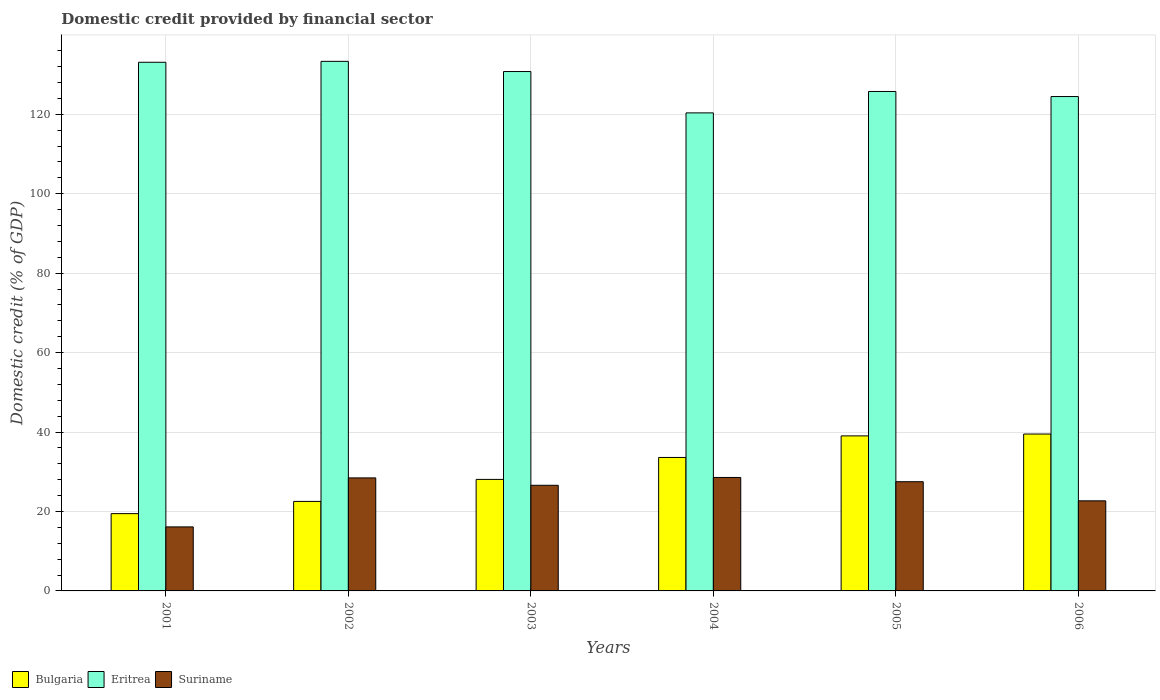Are the number of bars per tick equal to the number of legend labels?
Give a very brief answer. Yes. Are the number of bars on each tick of the X-axis equal?
Provide a short and direct response. Yes. What is the domestic credit in Bulgaria in 2004?
Keep it short and to the point. 33.6. Across all years, what is the maximum domestic credit in Eritrea?
Make the answer very short. 133.31. Across all years, what is the minimum domestic credit in Bulgaria?
Your response must be concise. 19.46. In which year was the domestic credit in Bulgaria minimum?
Your answer should be compact. 2001. What is the total domestic credit in Suriname in the graph?
Make the answer very short. 149.89. What is the difference between the domestic credit in Eritrea in 2001 and that in 2006?
Ensure brevity in your answer.  8.63. What is the difference between the domestic credit in Suriname in 2003 and the domestic credit in Bulgaria in 2004?
Ensure brevity in your answer.  -7.01. What is the average domestic credit in Suriname per year?
Ensure brevity in your answer.  24.98. In the year 2005, what is the difference between the domestic credit in Eritrea and domestic credit in Suriname?
Your answer should be very brief. 98.24. In how many years, is the domestic credit in Eritrea greater than 24 %?
Your answer should be very brief. 6. What is the ratio of the domestic credit in Eritrea in 2002 to that in 2004?
Offer a very short reply. 1.11. Is the domestic credit in Suriname in 2002 less than that in 2005?
Your response must be concise. No. What is the difference between the highest and the second highest domestic credit in Eritrea?
Make the answer very short. 0.23. What is the difference between the highest and the lowest domestic credit in Bulgaria?
Ensure brevity in your answer.  20.04. What does the 3rd bar from the left in 2001 represents?
Give a very brief answer. Suriname. What does the 1st bar from the right in 2003 represents?
Provide a short and direct response. Suriname. Is it the case that in every year, the sum of the domestic credit in Bulgaria and domestic credit in Suriname is greater than the domestic credit in Eritrea?
Ensure brevity in your answer.  No. Are all the bars in the graph horizontal?
Ensure brevity in your answer.  No. Are the values on the major ticks of Y-axis written in scientific E-notation?
Keep it short and to the point. No. Does the graph contain any zero values?
Give a very brief answer. No. Where does the legend appear in the graph?
Keep it short and to the point. Bottom left. How many legend labels are there?
Your response must be concise. 3. What is the title of the graph?
Your answer should be very brief. Domestic credit provided by financial sector. Does "Bulgaria" appear as one of the legend labels in the graph?
Give a very brief answer. Yes. What is the label or title of the Y-axis?
Keep it short and to the point. Domestic credit (% of GDP). What is the Domestic credit (% of GDP) in Bulgaria in 2001?
Keep it short and to the point. 19.46. What is the Domestic credit (% of GDP) in Eritrea in 2001?
Your answer should be very brief. 133.08. What is the Domestic credit (% of GDP) in Suriname in 2001?
Keep it short and to the point. 16.12. What is the Domestic credit (% of GDP) of Bulgaria in 2002?
Ensure brevity in your answer.  22.53. What is the Domestic credit (% of GDP) of Eritrea in 2002?
Provide a succinct answer. 133.31. What is the Domestic credit (% of GDP) of Suriname in 2002?
Provide a short and direct response. 28.45. What is the Domestic credit (% of GDP) in Bulgaria in 2003?
Offer a terse response. 28.07. What is the Domestic credit (% of GDP) in Eritrea in 2003?
Provide a short and direct response. 130.74. What is the Domestic credit (% of GDP) of Suriname in 2003?
Offer a terse response. 26.59. What is the Domestic credit (% of GDP) in Bulgaria in 2004?
Your response must be concise. 33.6. What is the Domestic credit (% of GDP) of Eritrea in 2004?
Your answer should be very brief. 120.34. What is the Domestic credit (% of GDP) in Suriname in 2004?
Offer a very short reply. 28.56. What is the Domestic credit (% of GDP) in Bulgaria in 2005?
Provide a short and direct response. 39.03. What is the Domestic credit (% of GDP) of Eritrea in 2005?
Keep it short and to the point. 125.73. What is the Domestic credit (% of GDP) in Suriname in 2005?
Offer a very short reply. 27.49. What is the Domestic credit (% of GDP) of Bulgaria in 2006?
Your response must be concise. 39.49. What is the Domestic credit (% of GDP) in Eritrea in 2006?
Keep it short and to the point. 124.45. What is the Domestic credit (% of GDP) of Suriname in 2006?
Keep it short and to the point. 22.68. Across all years, what is the maximum Domestic credit (% of GDP) of Bulgaria?
Your answer should be compact. 39.49. Across all years, what is the maximum Domestic credit (% of GDP) of Eritrea?
Make the answer very short. 133.31. Across all years, what is the maximum Domestic credit (% of GDP) of Suriname?
Keep it short and to the point. 28.56. Across all years, what is the minimum Domestic credit (% of GDP) in Bulgaria?
Offer a terse response. 19.46. Across all years, what is the minimum Domestic credit (% of GDP) of Eritrea?
Your answer should be compact. 120.34. Across all years, what is the minimum Domestic credit (% of GDP) in Suriname?
Your response must be concise. 16.12. What is the total Domestic credit (% of GDP) of Bulgaria in the graph?
Provide a succinct answer. 182.18. What is the total Domestic credit (% of GDP) in Eritrea in the graph?
Give a very brief answer. 767.64. What is the total Domestic credit (% of GDP) in Suriname in the graph?
Give a very brief answer. 149.89. What is the difference between the Domestic credit (% of GDP) in Bulgaria in 2001 and that in 2002?
Ensure brevity in your answer.  -3.07. What is the difference between the Domestic credit (% of GDP) of Eritrea in 2001 and that in 2002?
Offer a terse response. -0.23. What is the difference between the Domestic credit (% of GDP) of Suriname in 2001 and that in 2002?
Your response must be concise. -12.33. What is the difference between the Domestic credit (% of GDP) in Bulgaria in 2001 and that in 2003?
Provide a short and direct response. -8.62. What is the difference between the Domestic credit (% of GDP) in Eritrea in 2001 and that in 2003?
Keep it short and to the point. 2.33. What is the difference between the Domestic credit (% of GDP) in Suriname in 2001 and that in 2003?
Offer a terse response. -10.47. What is the difference between the Domestic credit (% of GDP) in Bulgaria in 2001 and that in 2004?
Ensure brevity in your answer.  -14.14. What is the difference between the Domestic credit (% of GDP) of Eritrea in 2001 and that in 2004?
Your response must be concise. 12.74. What is the difference between the Domestic credit (% of GDP) of Suriname in 2001 and that in 2004?
Keep it short and to the point. -12.45. What is the difference between the Domestic credit (% of GDP) of Bulgaria in 2001 and that in 2005?
Give a very brief answer. -19.57. What is the difference between the Domestic credit (% of GDP) of Eritrea in 2001 and that in 2005?
Keep it short and to the point. 7.35. What is the difference between the Domestic credit (% of GDP) of Suriname in 2001 and that in 2005?
Your response must be concise. -11.37. What is the difference between the Domestic credit (% of GDP) in Bulgaria in 2001 and that in 2006?
Your answer should be compact. -20.04. What is the difference between the Domestic credit (% of GDP) in Eritrea in 2001 and that in 2006?
Offer a very short reply. 8.63. What is the difference between the Domestic credit (% of GDP) in Suriname in 2001 and that in 2006?
Make the answer very short. -6.56. What is the difference between the Domestic credit (% of GDP) in Bulgaria in 2002 and that in 2003?
Ensure brevity in your answer.  -5.54. What is the difference between the Domestic credit (% of GDP) in Eritrea in 2002 and that in 2003?
Offer a very short reply. 2.56. What is the difference between the Domestic credit (% of GDP) of Suriname in 2002 and that in 2003?
Offer a terse response. 1.86. What is the difference between the Domestic credit (% of GDP) of Bulgaria in 2002 and that in 2004?
Provide a succinct answer. -11.06. What is the difference between the Domestic credit (% of GDP) of Eritrea in 2002 and that in 2004?
Offer a terse response. 12.97. What is the difference between the Domestic credit (% of GDP) in Suriname in 2002 and that in 2004?
Ensure brevity in your answer.  -0.11. What is the difference between the Domestic credit (% of GDP) in Bulgaria in 2002 and that in 2005?
Your response must be concise. -16.5. What is the difference between the Domestic credit (% of GDP) in Eritrea in 2002 and that in 2005?
Make the answer very short. 7.58. What is the difference between the Domestic credit (% of GDP) in Suriname in 2002 and that in 2005?
Keep it short and to the point. 0.96. What is the difference between the Domestic credit (% of GDP) of Bulgaria in 2002 and that in 2006?
Provide a succinct answer. -16.96. What is the difference between the Domestic credit (% of GDP) of Eritrea in 2002 and that in 2006?
Provide a short and direct response. 8.86. What is the difference between the Domestic credit (% of GDP) in Suriname in 2002 and that in 2006?
Ensure brevity in your answer.  5.77. What is the difference between the Domestic credit (% of GDP) in Bulgaria in 2003 and that in 2004?
Your answer should be compact. -5.52. What is the difference between the Domestic credit (% of GDP) of Eritrea in 2003 and that in 2004?
Offer a terse response. 10.41. What is the difference between the Domestic credit (% of GDP) in Suriname in 2003 and that in 2004?
Your response must be concise. -1.97. What is the difference between the Domestic credit (% of GDP) in Bulgaria in 2003 and that in 2005?
Keep it short and to the point. -10.95. What is the difference between the Domestic credit (% of GDP) in Eritrea in 2003 and that in 2005?
Provide a succinct answer. 5.02. What is the difference between the Domestic credit (% of GDP) in Suriname in 2003 and that in 2005?
Ensure brevity in your answer.  -0.9. What is the difference between the Domestic credit (% of GDP) in Bulgaria in 2003 and that in 2006?
Offer a very short reply. -11.42. What is the difference between the Domestic credit (% of GDP) of Eritrea in 2003 and that in 2006?
Your response must be concise. 6.29. What is the difference between the Domestic credit (% of GDP) in Suriname in 2003 and that in 2006?
Offer a very short reply. 3.91. What is the difference between the Domestic credit (% of GDP) in Bulgaria in 2004 and that in 2005?
Your response must be concise. -5.43. What is the difference between the Domestic credit (% of GDP) of Eritrea in 2004 and that in 2005?
Your response must be concise. -5.39. What is the difference between the Domestic credit (% of GDP) of Suriname in 2004 and that in 2005?
Offer a very short reply. 1.07. What is the difference between the Domestic credit (% of GDP) of Bulgaria in 2004 and that in 2006?
Give a very brief answer. -5.9. What is the difference between the Domestic credit (% of GDP) in Eritrea in 2004 and that in 2006?
Make the answer very short. -4.11. What is the difference between the Domestic credit (% of GDP) in Suriname in 2004 and that in 2006?
Provide a short and direct response. 5.89. What is the difference between the Domestic credit (% of GDP) of Bulgaria in 2005 and that in 2006?
Your answer should be compact. -0.47. What is the difference between the Domestic credit (% of GDP) in Eritrea in 2005 and that in 2006?
Give a very brief answer. 1.28. What is the difference between the Domestic credit (% of GDP) in Suriname in 2005 and that in 2006?
Your response must be concise. 4.81. What is the difference between the Domestic credit (% of GDP) of Bulgaria in 2001 and the Domestic credit (% of GDP) of Eritrea in 2002?
Offer a terse response. -113.85. What is the difference between the Domestic credit (% of GDP) of Bulgaria in 2001 and the Domestic credit (% of GDP) of Suriname in 2002?
Your answer should be compact. -8.99. What is the difference between the Domestic credit (% of GDP) in Eritrea in 2001 and the Domestic credit (% of GDP) in Suriname in 2002?
Make the answer very short. 104.63. What is the difference between the Domestic credit (% of GDP) of Bulgaria in 2001 and the Domestic credit (% of GDP) of Eritrea in 2003?
Your answer should be very brief. -111.29. What is the difference between the Domestic credit (% of GDP) in Bulgaria in 2001 and the Domestic credit (% of GDP) in Suriname in 2003?
Your response must be concise. -7.13. What is the difference between the Domestic credit (% of GDP) of Eritrea in 2001 and the Domestic credit (% of GDP) of Suriname in 2003?
Your answer should be very brief. 106.49. What is the difference between the Domestic credit (% of GDP) in Bulgaria in 2001 and the Domestic credit (% of GDP) in Eritrea in 2004?
Ensure brevity in your answer.  -100.88. What is the difference between the Domestic credit (% of GDP) of Bulgaria in 2001 and the Domestic credit (% of GDP) of Suriname in 2004?
Provide a succinct answer. -9.11. What is the difference between the Domestic credit (% of GDP) of Eritrea in 2001 and the Domestic credit (% of GDP) of Suriname in 2004?
Provide a short and direct response. 104.52. What is the difference between the Domestic credit (% of GDP) of Bulgaria in 2001 and the Domestic credit (% of GDP) of Eritrea in 2005?
Provide a short and direct response. -106.27. What is the difference between the Domestic credit (% of GDP) in Bulgaria in 2001 and the Domestic credit (% of GDP) in Suriname in 2005?
Offer a terse response. -8.03. What is the difference between the Domestic credit (% of GDP) in Eritrea in 2001 and the Domestic credit (% of GDP) in Suriname in 2005?
Your response must be concise. 105.59. What is the difference between the Domestic credit (% of GDP) of Bulgaria in 2001 and the Domestic credit (% of GDP) of Eritrea in 2006?
Offer a very short reply. -104.99. What is the difference between the Domestic credit (% of GDP) in Bulgaria in 2001 and the Domestic credit (% of GDP) in Suriname in 2006?
Offer a very short reply. -3.22. What is the difference between the Domestic credit (% of GDP) in Eritrea in 2001 and the Domestic credit (% of GDP) in Suriname in 2006?
Keep it short and to the point. 110.4. What is the difference between the Domestic credit (% of GDP) in Bulgaria in 2002 and the Domestic credit (% of GDP) in Eritrea in 2003?
Offer a terse response. -108.21. What is the difference between the Domestic credit (% of GDP) of Bulgaria in 2002 and the Domestic credit (% of GDP) of Suriname in 2003?
Your response must be concise. -4.06. What is the difference between the Domestic credit (% of GDP) of Eritrea in 2002 and the Domestic credit (% of GDP) of Suriname in 2003?
Keep it short and to the point. 106.72. What is the difference between the Domestic credit (% of GDP) of Bulgaria in 2002 and the Domestic credit (% of GDP) of Eritrea in 2004?
Your response must be concise. -97.8. What is the difference between the Domestic credit (% of GDP) in Bulgaria in 2002 and the Domestic credit (% of GDP) in Suriname in 2004?
Provide a short and direct response. -6.03. What is the difference between the Domestic credit (% of GDP) of Eritrea in 2002 and the Domestic credit (% of GDP) of Suriname in 2004?
Provide a short and direct response. 104.75. What is the difference between the Domestic credit (% of GDP) in Bulgaria in 2002 and the Domestic credit (% of GDP) in Eritrea in 2005?
Your response must be concise. -103.19. What is the difference between the Domestic credit (% of GDP) in Bulgaria in 2002 and the Domestic credit (% of GDP) in Suriname in 2005?
Provide a short and direct response. -4.96. What is the difference between the Domestic credit (% of GDP) in Eritrea in 2002 and the Domestic credit (% of GDP) in Suriname in 2005?
Your answer should be very brief. 105.82. What is the difference between the Domestic credit (% of GDP) in Bulgaria in 2002 and the Domestic credit (% of GDP) in Eritrea in 2006?
Make the answer very short. -101.92. What is the difference between the Domestic credit (% of GDP) in Bulgaria in 2002 and the Domestic credit (% of GDP) in Suriname in 2006?
Provide a short and direct response. -0.14. What is the difference between the Domestic credit (% of GDP) in Eritrea in 2002 and the Domestic credit (% of GDP) in Suriname in 2006?
Provide a succinct answer. 110.63. What is the difference between the Domestic credit (% of GDP) of Bulgaria in 2003 and the Domestic credit (% of GDP) of Eritrea in 2004?
Keep it short and to the point. -92.26. What is the difference between the Domestic credit (% of GDP) in Bulgaria in 2003 and the Domestic credit (% of GDP) in Suriname in 2004?
Offer a very short reply. -0.49. What is the difference between the Domestic credit (% of GDP) in Eritrea in 2003 and the Domestic credit (% of GDP) in Suriname in 2004?
Give a very brief answer. 102.18. What is the difference between the Domestic credit (% of GDP) of Bulgaria in 2003 and the Domestic credit (% of GDP) of Eritrea in 2005?
Make the answer very short. -97.65. What is the difference between the Domestic credit (% of GDP) in Bulgaria in 2003 and the Domestic credit (% of GDP) in Suriname in 2005?
Your response must be concise. 0.58. What is the difference between the Domestic credit (% of GDP) of Eritrea in 2003 and the Domestic credit (% of GDP) of Suriname in 2005?
Keep it short and to the point. 103.25. What is the difference between the Domestic credit (% of GDP) of Bulgaria in 2003 and the Domestic credit (% of GDP) of Eritrea in 2006?
Ensure brevity in your answer.  -96.38. What is the difference between the Domestic credit (% of GDP) of Bulgaria in 2003 and the Domestic credit (% of GDP) of Suriname in 2006?
Offer a very short reply. 5.4. What is the difference between the Domestic credit (% of GDP) of Eritrea in 2003 and the Domestic credit (% of GDP) of Suriname in 2006?
Give a very brief answer. 108.07. What is the difference between the Domestic credit (% of GDP) in Bulgaria in 2004 and the Domestic credit (% of GDP) in Eritrea in 2005?
Make the answer very short. -92.13. What is the difference between the Domestic credit (% of GDP) in Bulgaria in 2004 and the Domestic credit (% of GDP) in Suriname in 2005?
Ensure brevity in your answer.  6.11. What is the difference between the Domestic credit (% of GDP) of Eritrea in 2004 and the Domestic credit (% of GDP) of Suriname in 2005?
Keep it short and to the point. 92.85. What is the difference between the Domestic credit (% of GDP) in Bulgaria in 2004 and the Domestic credit (% of GDP) in Eritrea in 2006?
Your response must be concise. -90.85. What is the difference between the Domestic credit (% of GDP) of Bulgaria in 2004 and the Domestic credit (% of GDP) of Suriname in 2006?
Offer a very short reply. 10.92. What is the difference between the Domestic credit (% of GDP) in Eritrea in 2004 and the Domestic credit (% of GDP) in Suriname in 2006?
Ensure brevity in your answer.  97.66. What is the difference between the Domestic credit (% of GDP) in Bulgaria in 2005 and the Domestic credit (% of GDP) in Eritrea in 2006?
Ensure brevity in your answer.  -85.42. What is the difference between the Domestic credit (% of GDP) of Bulgaria in 2005 and the Domestic credit (% of GDP) of Suriname in 2006?
Give a very brief answer. 16.35. What is the difference between the Domestic credit (% of GDP) in Eritrea in 2005 and the Domestic credit (% of GDP) in Suriname in 2006?
Your answer should be very brief. 103.05. What is the average Domestic credit (% of GDP) in Bulgaria per year?
Keep it short and to the point. 30.36. What is the average Domestic credit (% of GDP) in Eritrea per year?
Your answer should be compact. 127.94. What is the average Domestic credit (% of GDP) in Suriname per year?
Ensure brevity in your answer.  24.98. In the year 2001, what is the difference between the Domestic credit (% of GDP) in Bulgaria and Domestic credit (% of GDP) in Eritrea?
Make the answer very short. -113.62. In the year 2001, what is the difference between the Domestic credit (% of GDP) of Bulgaria and Domestic credit (% of GDP) of Suriname?
Offer a very short reply. 3.34. In the year 2001, what is the difference between the Domestic credit (% of GDP) of Eritrea and Domestic credit (% of GDP) of Suriname?
Keep it short and to the point. 116.96. In the year 2002, what is the difference between the Domestic credit (% of GDP) of Bulgaria and Domestic credit (% of GDP) of Eritrea?
Your answer should be compact. -110.78. In the year 2002, what is the difference between the Domestic credit (% of GDP) of Bulgaria and Domestic credit (% of GDP) of Suriname?
Your answer should be very brief. -5.92. In the year 2002, what is the difference between the Domestic credit (% of GDP) in Eritrea and Domestic credit (% of GDP) in Suriname?
Your answer should be very brief. 104.86. In the year 2003, what is the difference between the Domestic credit (% of GDP) in Bulgaria and Domestic credit (% of GDP) in Eritrea?
Offer a terse response. -102.67. In the year 2003, what is the difference between the Domestic credit (% of GDP) of Bulgaria and Domestic credit (% of GDP) of Suriname?
Give a very brief answer. 1.48. In the year 2003, what is the difference between the Domestic credit (% of GDP) in Eritrea and Domestic credit (% of GDP) in Suriname?
Make the answer very short. 104.15. In the year 2004, what is the difference between the Domestic credit (% of GDP) of Bulgaria and Domestic credit (% of GDP) of Eritrea?
Your answer should be compact. -86.74. In the year 2004, what is the difference between the Domestic credit (% of GDP) in Bulgaria and Domestic credit (% of GDP) in Suriname?
Provide a short and direct response. 5.03. In the year 2004, what is the difference between the Domestic credit (% of GDP) in Eritrea and Domestic credit (% of GDP) in Suriname?
Ensure brevity in your answer.  91.77. In the year 2005, what is the difference between the Domestic credit (% of GDP) of Bulgaria and Domestic credit (% of GDP) of Eritrea?
Your answer should be compact. -86.7. In the year 2005, what is the difference between the Domestic credit (% of GDP) of Bulgaria and Domestic credit (% of GDP) of Suriname?
Provide a short and direct response. 11.54. In the year 2005, what is the difference between the Domestic credit (% of GDP) of Eritrea and Domestic credit (% of GDP) of Suriname?
Offer a very short reply. 98.24. In the year 2006, what is the difference between the Domestic credit (% of GDP) in Bulgaria and Domestic credit (% of GDP) in Eritrea?
Your answer should be very brief. -84.96. In the year 2006, what is the difference between the Domestic credit (% of GDP) of Bulgaria and Domestic credit (% of GDP) of Suriname?
Keep it short and to the point. 16.82. In the year 2006, what is the difference between the Domestic credit (% of GDP) in Eritrea and Domestic credit (% of GDP) in Suriname?
Make the answer very short. 101.77. What is the ratio of the Domestic credit (% of GDP) in Bulgaria in 2001 to that in 2002?
Your answer should be compact. 0.86. What is the ratio of the Domestic credit (% of GDP) in Suriname in 2001 to that in 2002?
Provide a succinct answer. 0.57. What is the ratio of the Domestic credit (% of GDP) in Bulgaria in 2001 to that in 2003?
Keep it short and to the point. 0.69. What is the ratio of the Domestic credit (% of GDP) of Eritrea in 2001 to that in 2003?
Provide a short and direct response. 1.02. What is the ratio of the Domestic credit (% of GDP) in Suriname in 2001 to that in 2003?
Offer a very short reply. 0.61. What is the ratio of the Domestic credit (% of GDP) in Bulgaria in 2001 to that in 2004?
Your answer should be very brief. 0.58. What is the ratio of the Domestic credit (% of GDP) of Eritrea in 2001 to that in 2004?
Ensure brevity in your answer.  1.11. What is the ratio of the Domestic credit (% of GDP) of Suriname in 2001 to that in 2004?
Provide a succinct answer. 0.56. What is the ratio of the Domestic credit (% of GDP) in Bulgaria in 2001 to that in 2005?
Give a very brief answer. 0.5. What is the ratio of the Domestic credit (% of GDP) of Eritrea in 2001 to that in 2005?
Your answer should be very brief. 1.06. What is the ratio of the Domestic credit (% of GDP) in Suriname in 2001 to that in 2005?
Make the answer very short. 0.59. What is the ratio of the Domestic credit (% of GDP) in Bulgaria in 2001 to that in 2006?
Give a very brief answer. 0.49. What is the ratio of the Domestic credit (% of GDP) in Eritrea in 2001 to that in 2006?
Your response must be concise. 1.07. What is the ratio of the Domestic credit (% of GDP) in Suriname in 2001 to that in 2006?
Provide a short and direct response. 0.71. What is the ratio of the Domestic credit (% of GDP) in Bulgaria in 2002 to that in 2003?
Your answer should be compact. 0.8. What is the ratio of the Domestic credit (% of GDP) of Eritrea in 2002 to that in 2003?
Your answer should be very brief. 1.02. What is the ratio of the Domestic credit (% of GDP) in Suriname in 2002 to that in 2003?
Ensure brevity in your answer.  1.07. What is the ratio of the Domestic credit (% of GDP) of Bulgaria in 2002 to that in 2004?
Your answer should be compact. 0.67. What is the ratio of the Domestic credit (% of GDP) of Eritrea in 2002 to that in 2004?
Make the answer very short. 1.11. What is the ratio of the Domestic credit (% of GDP) in Suriname in 2002 to that in 2004?
Your answer should be very brief. 1. What is the ratio of the Domestic credit (% of GDP) of Bulgaria in 2002 to that in 2005?
Offer a terse response. 0.58. What is the ratio of the Domestic credit (% of GDP) of Eritrea in 2002 to that in 2005?
Offer a very short reply. 1.06. What is the ratio of the Domestic credit (% of GDP) of Suriname in 2002 to that in 2005?
Offer a very short reply. 1.03. What is the ratio of the Domestic credit (% of GDP) in Bulgaria in 2002 to that in 2006?
Keep it short and to the point. 0.57. What is the ratio of the Domestic credit (% of GDP) in Eritrea in 2002 to that in 2006?
Give a very brief answer. 1.07. What is the ratio of the Domestic credit (% of GDP) in Suriname in 2002 to that in 2006?
Your response must be concise. 1.25. What is the ratio of the Domestic credit (% of GDP) in Bulgaria in 2003 to that in 2004?
Offer a terse response. 0.84. What is the ratio of the Domestic credit (% of GDP) in Eritrea in 2003 to that in 2004?
Give a very brief answer. 1.09. What is the ratio of the Domestic credit (% of GDP) of Suriname in 2003 to that in 2004?
Your response must be concise. 0.93. What is the ratio of the Domestic credit (% of GDP) in Bulgaria in 2003 to that in 2005?
Provide a short and direct response. 0.72. What is the ratio of the Domestic credit (% of GDP) in Eritrea in 2003 to that in 2005?
Make the answer very short. 1.04. What is the ratio of the Domestic credit (% of GDP) in Suriname in 2003 to that in 2005?
Your answer should be compact. 0.97. What is the ratio of the Domestic credit (% of GDP) of Bulgaria in 2003 to that in 2006?
Give a very brief answer. 0.71. What is the ratio of the Domestic credit (% of GDP) in Eritrea in 2003 to that in 2006?
Provide a succinct answer. 1.05. What is the ratio of the Domestic credit (% of GDP) in Suriname in 2003 to that in 2006?
Provide a short and direct response. 1.17. What is the ratio of the Domestic credit (% of GDP) in Bulgaria in 2004 to that in 2005?
Make the answer very short. 0.86. What is the ratio of the Domestic credit (% of GDP) in Eritrea in 2004 to that in 2005?
Provide a short and direct response. 0.96. What is the ratio of the Domestic credit (% of GDP) of Suriname in 2004 to that in 2005?
Ensure brevity in your answer.  1.04. What is the ratio of the Domestic credit (% of GDP) of Bulgaria in 2004 to that in 2006?
Ensure brevity in your answer.  0.85. What is the ratio of the Domestic credit (% of GDP) in Eritrea in 2004 to that in 2006?
Offer a very short reply. 0.97. What is the ratio of the Domestic credit (% of GDP) in Suriname in 2004 to that in 2006?
Your answer should be very brief. 1.26. What is the ratio of the Domestic credit (% of GDP) of Bulgaria in 2005 to that in 2006?
Provide a succinct answer. 0.99. What is the ratio of the Domestic credit (% of GDP) in Eritrea in 2005 to that in 2006?
Make the answer very short. 1.01. What is the ratio of the Domestic credit (% of GDP) of Suriname in 2005 to that in 2006?
Provide a short and direct response. 1.21. What is the difference between the highest and the second highest Domestic credit (% of GDP) in Bulgaria?
Ensure brevity in your answer.  0.47. What is the difference between the highest and the second highest Domestic credit (% of GDP) in Eritrea?
Keep it short and to the point. 0.23. What is the difference between the highest and the second highest Domestic credit (% of GDP) in Suriname?
Provide a short and direct response. 0.11. What is the difference between the highest and the lowest Domestic credit (% of GDP) of Bulgaria?
Offer a very short reply. 20.04. What is the difference between the highest and the lowest Domestic credit (% of GDP) in Eritrea?
Offer a very short reply. 12.97. What is the difference between the highest and the lowest Domestic credit (% of GDP) in Suriname?
Your answer should be very brief. 12.45. 